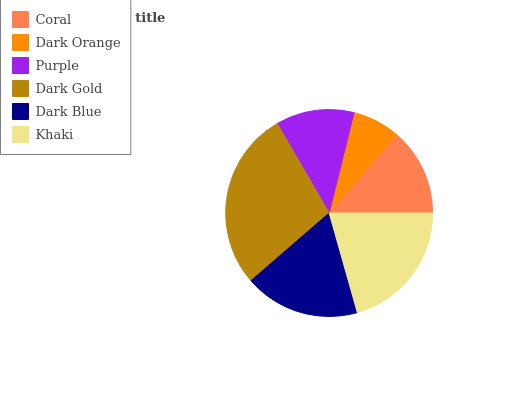Is Dark Orange the minimum?
Answer yes or no. Yes. Is Dark Gold the maximum?
Answer yes or no. Yes. Is Purple the minimum?
Answer yes or no. No. Is Purple the maximum?
Answer yes or no. No. Is Purple greater than Dark Orange?
Answer yes or no. Yes. Is Dark Orange less than Purple?
Answer yes or no. Yes. Is Dark Orange greater than Purple?
Answer yes or no. No. Is Purple less than Dark Orange?
Answer yes or no. No. Is Dark Blue the high median?
Answer yes or no. Yes. Is Coral the low median?
Answer yes or no. Yes. Is Dark Gold the high median?
Answer yes or no. No. Is Purple the low median?
Answer yes or no. No. 